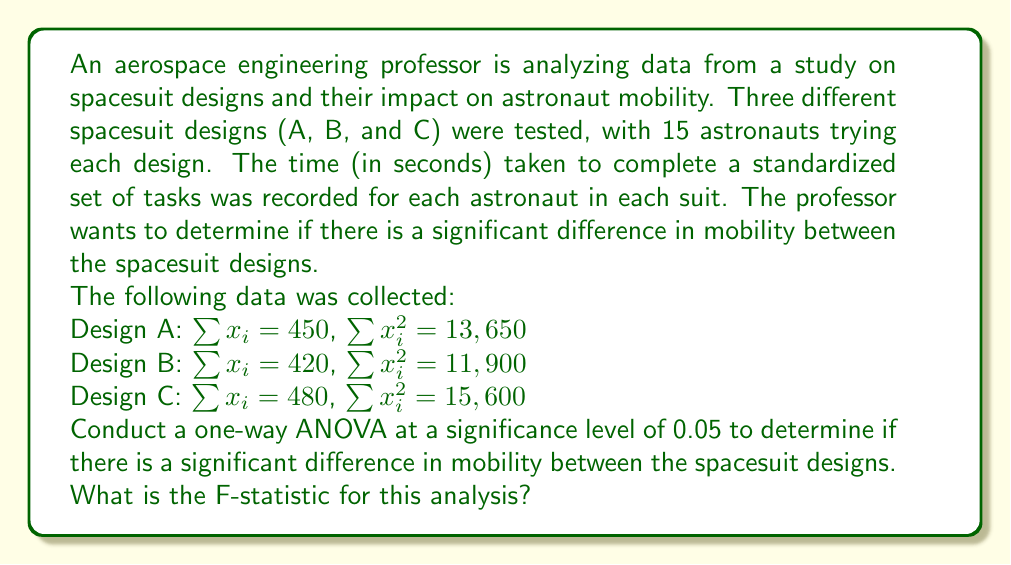Help me with this question. To conduct a one-way ANOVA, we need to follow these steps:

1. Calculate the total sum of squares (SST)
2. Calculate the between-groups sum of squares (SSB)
3. Calculate the within-groups sum of squares (SSW)
4. Calculate the degrees of freedom
5. Calculate the mean squares
6. Calculate the F-statistic

Step 1: Calculate SST
First, we need to find the grand mean:
$$\bar{X} = \frac{450 + 420 + 480}{45} = 30$$

Now, we can calculate SST:
$$SST = (13650 + 11900 + 15600) - 45(30^2) = 41150 - 40500 = 650$$

Step 2: Calculate SSB
$$SSB = 15(\frac{450^2 + 420^2 + 480^2}{15^2} - 30^2) = 15(902 - 900) = 30$$

Step 3: Calculate SSW
$$SSW = SST - SSB = 650 - 30 = 620$$

Step 4: Degrees of freedom
- Between groups: $df_B = k - 1 = 3 - 1 = 2$, where k is the number of groups
- Within groups: $df_W = N - k = 45 - 3 = 42$, where N is the total number of observations

Step 5: Calculate mean squares
$$MSB = \frac{SSB}{df_B} = \frac{30}{2} = 15$$
$$MSW = \frac{SSW}{df_W} = \frac{620}{42} = 14.7619$$

Step 6: Calculate F-statistic
$$F = \frac{MSB}{MSW} = \frac{15}{14.7619} = 1.0161$$
Answer: The F-statistic for this analysis is 1.0161. 